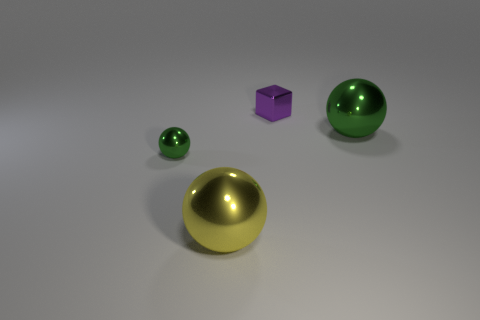Does the metallic ball right of the large yellow metal sphere have the same size as the green metallic ball that is on the left side of the small purple metallic cube?
Ensure brevity in your answer.  No. There is a thing that is to the right of the tiny green ball and on the left side of the purple cube; what material is it made of?
Provide a succinct answer. Metal. The other sphere that is the same color as the small shiny ball is what size?
Make the answer very short. Large. What number of other things are the same size as the purple cube?
Give a very brief answer. 1. What is the big ball that is on the right side of the large yellow shiny object made of?
Ensure brevity in your answer.  Metal. Is the shape of the purple thing the same as the small green shiny thing?
Ensure brevity in your answer.  No. How many other things are the same shape as the purple object?
Offer a terse response. 0. What is the color of the large sphere on the right side of the large yellow thing?
Make the answer very short. Green. Is the cube the same size as the yellow metal thing?
Offer a very short reply. No. What is the material of the large sphere that is left of the big shiny thing behind the yellow metal ball?
Offer a terse response. Metal. 